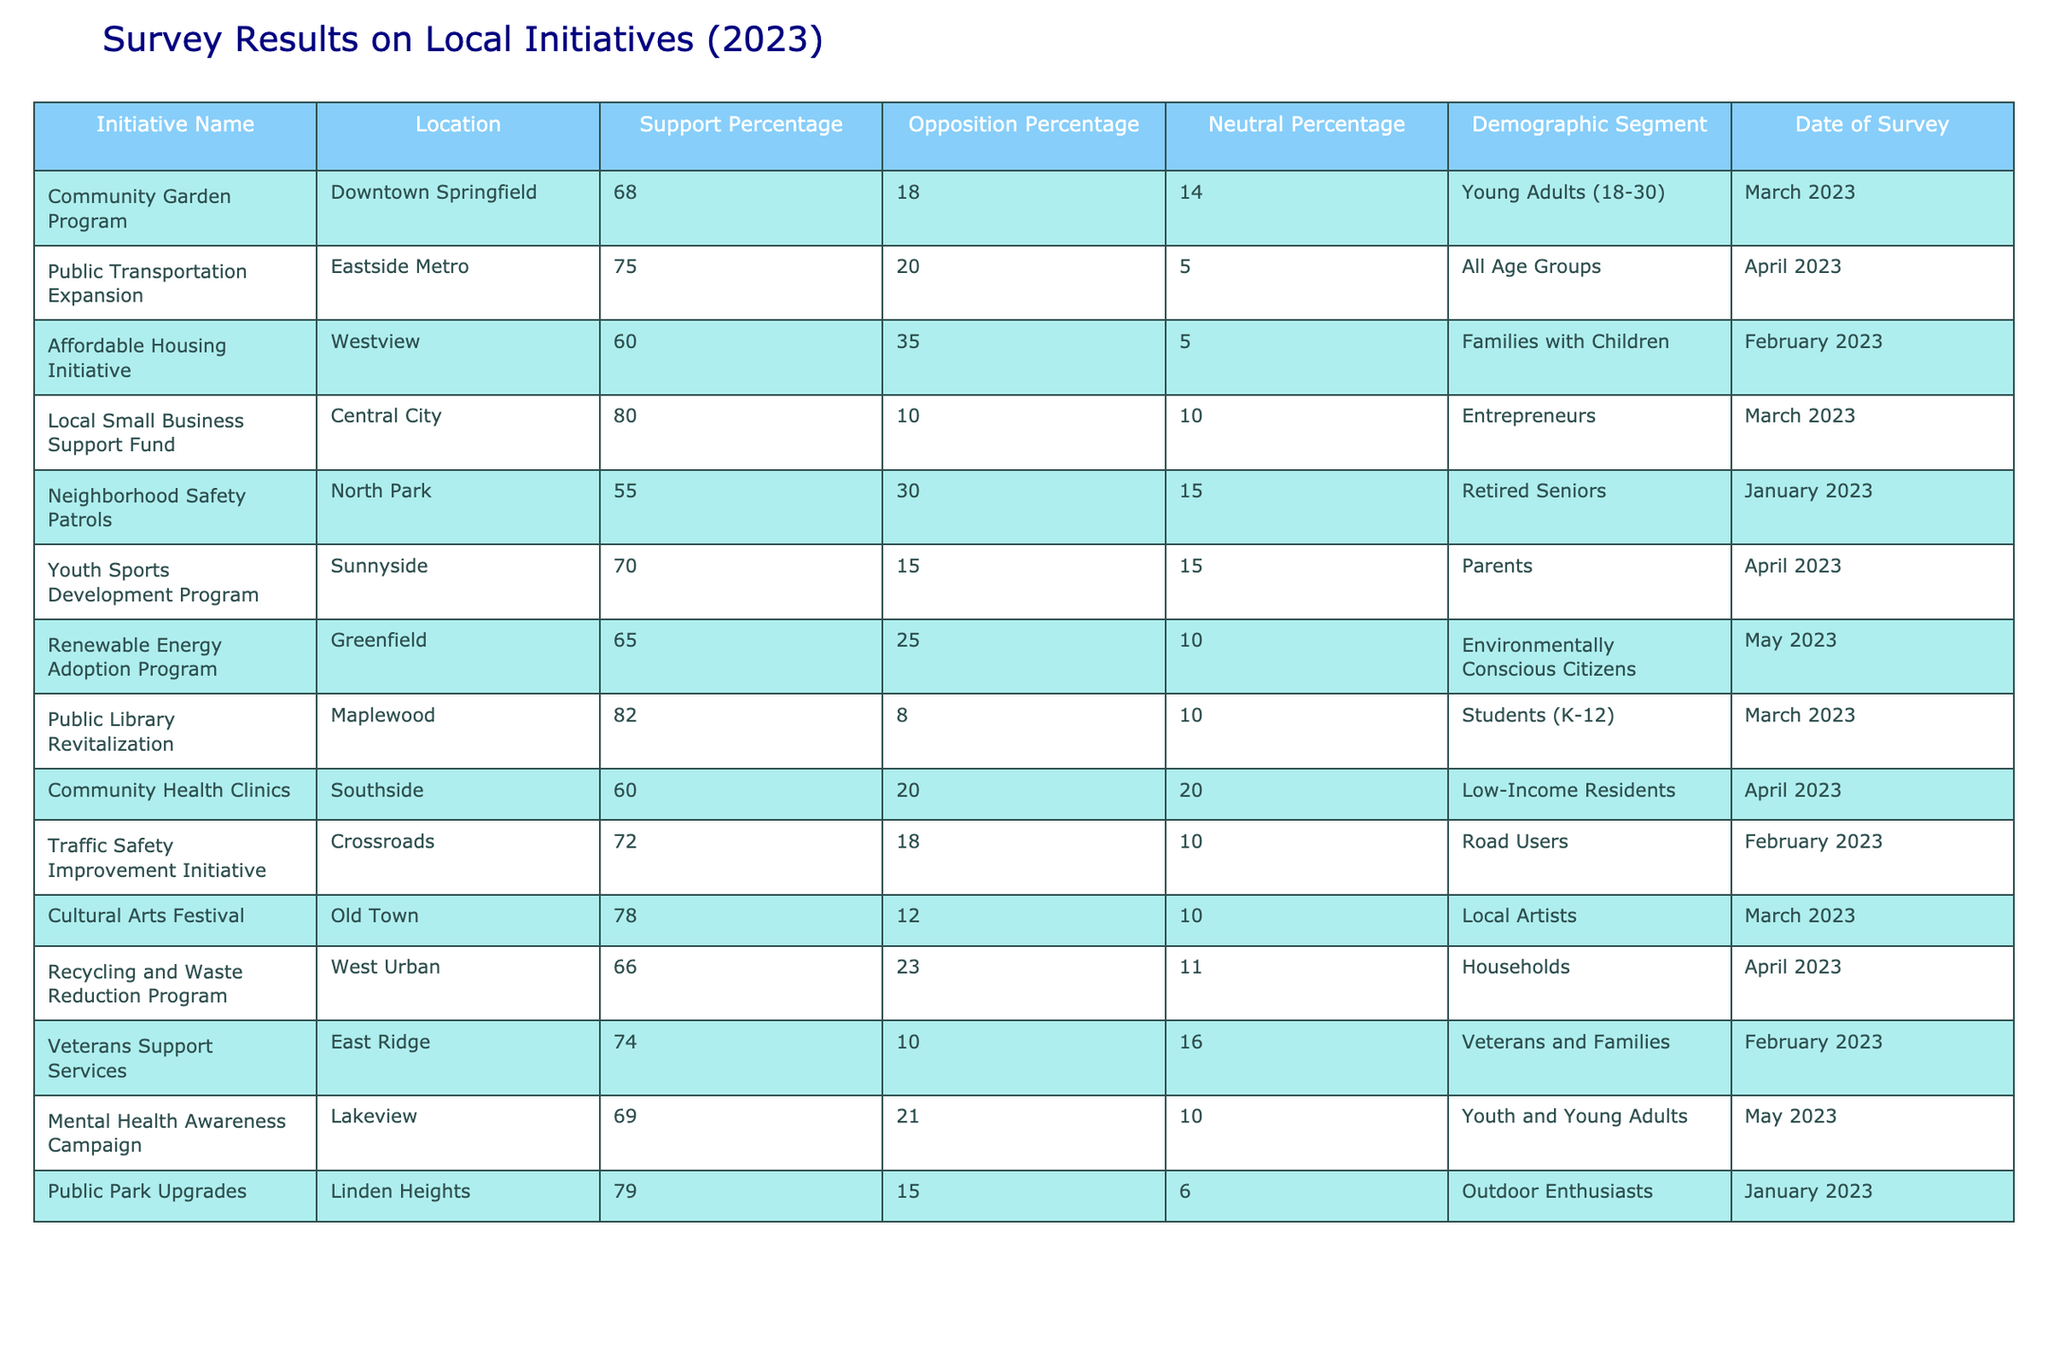What is the support percentage for the Community Garden Program? The support percentage for this initiative is directly listed in the table under "Support Percentage," which shows 68% for the Community Garden Program.
Answer: 68% Which initiative has the highest opposition percentage? By examining the "Opposition Percentage" column, Affordable Housing Initiative with 35% has the highest value compared to other initiatives.
Answer: Affordable Housing Initiative What is the average support percentage of the initiatives aimed at families with children? The support percentages for the initiatives aimed at families are 60% (Affordable Housing Initiative) and 70% (Youth Sports Development Program). Adding these gives 130%, and dividing by 2 yields an average of 65%.
Answer: 65% Is the support percentage for the Local Small Business Support Fund higher than the Mental Health Awareness Campaign? Local Small Business Support Fund has a support percentage of 80%, while the Mental Health Awareness Campaign has 69%. Since 80% is greater than 69%, the statement is true.
Answer: Yes Which initiative has the lowest support percentage among initiatives aimed at retired seniors and low-income residents? The Neighborhood Safety Patrols focused on retired seniors have a support percentage of 55%, while the Community Health Clinics aimed at low-income residents have 60%. Comparing these, the Neighborhood Safety Patrols have the lowest support percentage.
Answer: Neighborhood Safety Patrols What is the difference between the support percentages of the Public Transportation Expansion and the Public Library Revitalization? The Public Transportation Expansion has a support percentage of 75% and the Public Library Revitalization has 82%. The difference is 82% - 75% = 7%.
Answer: 7% Which demographic segment has shown the least support for their corresponding initiative? By comparing the support percentages, Neighborhood Safety Patrols for Retired Seniors has 55%, which is the lowest among all demographic segments’ initiatives.
Answer: Retired Seniors Can you find out which initiatives have support percentages greater than 70%? Initiatives with support percentages greater than 70% include Public Transportation Expansion (75%), Local Small Business Support Fund (80%), Public Library Revitalization (82%), Cultural Arts Festival (78%), and Public Park Upgrades (79%). Count reveals five initiatives exceed 70%.
Answer: 5 What percentage of the respondents were neutral about the Renewable Energy Adoption Program? The table lists the neutral percentage for the Renewable Energy Adoption Program as 10%.
Answer: 10% Which initiative shows the strongest overall support based on its support percentage? The initiative with the highest support percentage listed is the Public Library Revitalization at 82%.
Answer: Public Library Revitalization If you consider all research data, what is the median support percentage of the initiatives? Arranging the support percentages in order: 55%, 60%, 65%, 68%, 69%, 70%, 72%, 75%, 78%, 79%, 80%, 82% gives 11 values. The middle values (70% and 72%) average out to 71%.
Answer: 71% 